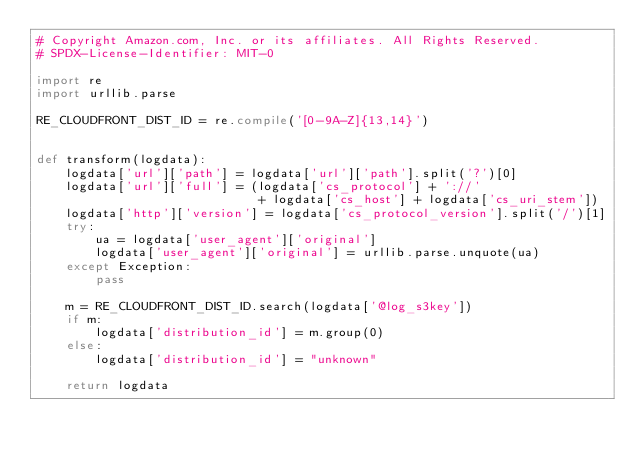Convert code to text. <code><loc_0><loc_0><loc_500><loc_500><_Python_># Copyright Amazon.com, Inc. or its affiliates. All Rights Reserved.
# SPDX-License-Identifier: MIT-0

import re
import urllib.parse

RE_CLOUDFRONT_DIST_ID = re.compile('[0-9A-Z]{13,14}')


def transform(logdata):
    logdata['url']['path'] = logdata['url']['path'].split('?')[0]
    logdata['url']['full'] = (logdata['cs_protocol'] + '://'
                              + logdata['cs_host'] + logdata['cs_uri_stem'])
    logdata['http']['version'] = logdata['cs_protocol_version'].split('/')[1]
    try:
        ua = logdata['user_agent']['original']
        logdata['user_agent']['original'] = urllib.parse.unquote(ua)
    except Exception:
        pass

    m = RE_CLOUDFRONT_DIST_ID.search(logdata['@log_s3key'])
    if m:
        logdata['distribution_id'] = m.group(0)
    else:
        logdata['distribution_id'] = "unknown"

    return logdata
</code> 